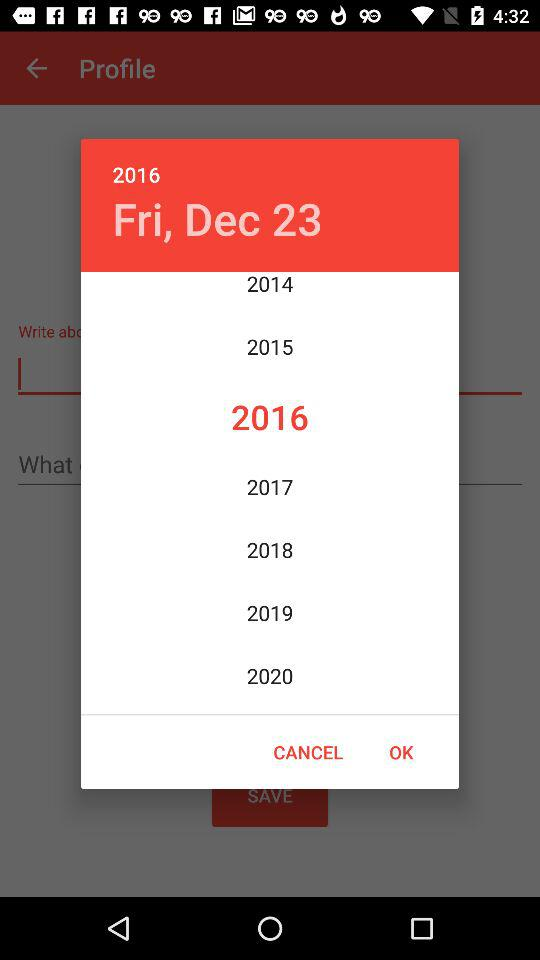What is the selected date? The selected date is Friday, December 23, 2016. 